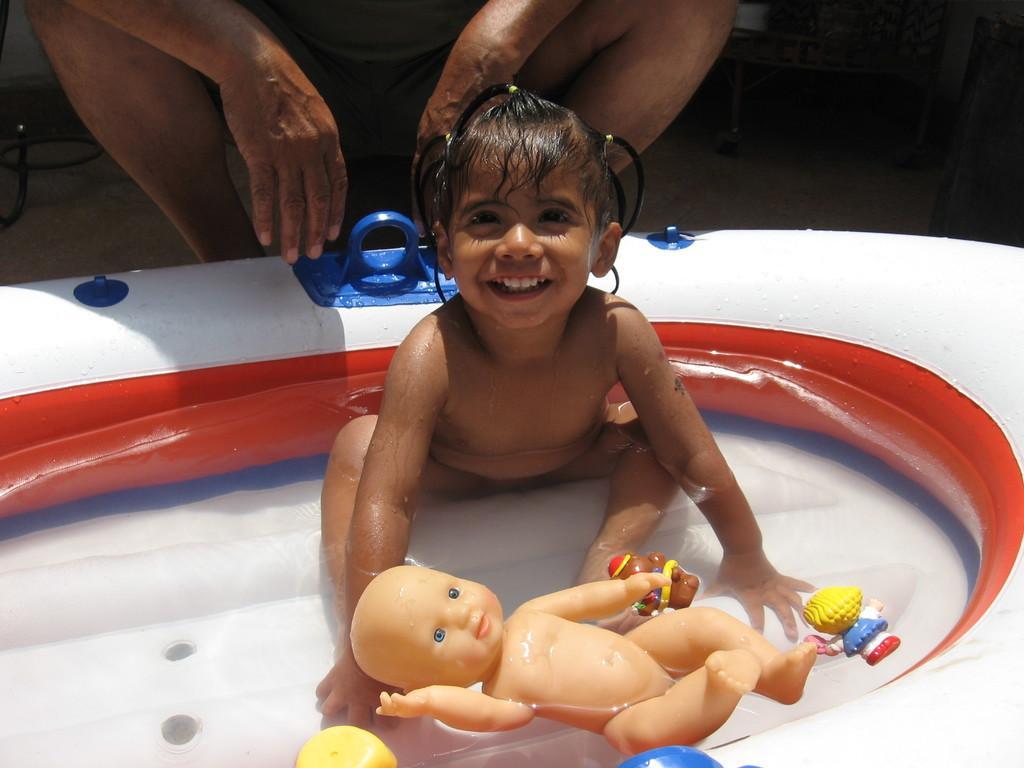Can you describe this image briefly? In this image a man is sitting behind a baby. A girl is sitting in a tub. The toys are floating in a water. 